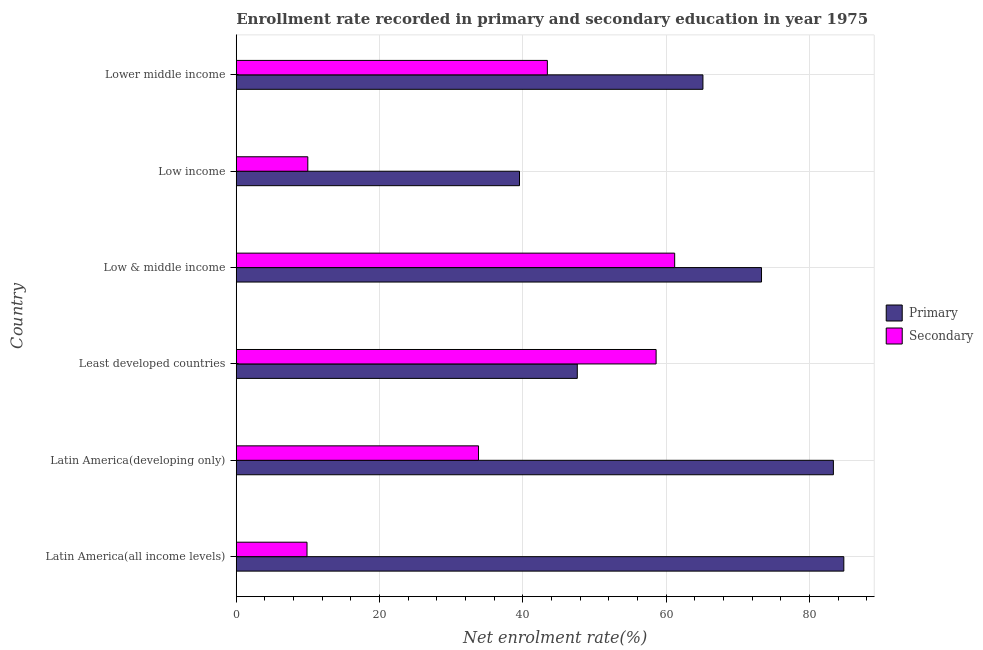How many groups of bars are there?
Offer a terse response. 6. Are the number of bars per tick equal to the number of legend labels?
Offer a terse response. Yes. Are the number of bars on each tick of the Y-axis equal?
Offer a very short reply. Yes. How many bars are there on the 5th tick from the top?
Your answer should be compact. 2. How many bars are there on the 4th tick from the bottom?
Give a very brief answer. 2. What is the label of the 4th group of bars from the top?
Keep it short and to the point. Least developed countries. In how many cases, is the number of bars for a given country not equal to the number of legend labels?
Offer a terse response. 0. What is the enrollment rate in primary education in Low income?
Provide a short and direct response. 39.53. Across all countries, what is the maximum enrollment rate in primary education?
Ensure brevity in your answer.  84.79. Across all countries, what is the minimum enrollment rate in secondary education?
Your response must be concise. 9.88. In which country was the enrollment rate in primary education maximum?
Provide a succinct answer. Latin America(all income levels). What is the total enrollment rate in primary education in the graph?
Provide a succinct answer. 393.66. What is the difference between the enrollment rate in secondary education in Low & middle income and that in Lower middle income?
Keep it short and to the point. 17.77. What is the difference between the enrollment rate in primary education in Least developed countries and the enrollment rate in secondary education in Low income?
Keep it short and to the point. 37.61. What is the average enrollment rate in primary education per country?
Provide a succinct answer. 65.61. What is the difference between the enrollment rate in secondary education and enrollment rate in primary education in Lower middle income?
Keep it short and to the point. -21.71. In how many countries, is the enrollment rate in primary education greater than 84 %?
Give a very brief answer. 1. What is the ratio of the enrollment rate in primary education in Latin America(developing only) to that in Low income?
Your answer should be very brief. 2.11. Is the difference between the enrollment rate in primary education in Least developed countries and Low income greater than the difference between the enrollment rate in secondary education in Least developed countries and Low income?
Keep it short and to the point. No. What is the difference between the highest and the second highest enrollment rate in secondary education?
Ensure brevity in your answer.  2.59. What is the difference between the highest and the lowest enrollment rate in primary education?
Ensure brevity in your answer.  45.26. What does the 1st bar from the top in Low & middle income represents?
Provide a short and direct response. Secondary. What does the 2nd bar from the bottom in Latin America(developing only) represents?
Your answer should be compact. Secondary. How many countries are there in the graph?
Ensure brevity in your answer.  6. Does the graph contain grids?
Provide a short and direct response. Yes. How are the legend labels stacked?
Your answer should be compact. Vertical. What is the title of the graph?
Your answer should be compact. Enrollment rate recorded in primary and secondary education in year 1975. What is the label or title of the X-axis?
Ensure brevity in your answer.  Net enrolment rate(%). What is the label or title of the Y-axis?
Your answer should be compact. Country. What is the Net enrolment rate(%) in Primary in Latin America(all income levels)?
Provide a succinct answer. 84.79. What is the Net enrolment rate(%) of Secondary in Latin America(all income levels)?
Make the answer very short. 9.88. What is the Net enrolment rate(%) in Primary in Latin America(developing only)?
Keep it short and to the point. 83.33. What is the Net enrolment rate(%) in Secondary in Latin America(developing only)?
Provide a short and direct response. 33.81. What is the Net enrolment rate(%) of Primary in Least developed countries?
Offer a terse response. 47.59. What is the Net enrolment rate(%) of Secondary in Least developed countries?
Your answer should be compact. 58.59. What is the Net enrolment rate(%) of Primary in Low & middle income?
Give a very brief answer. 73.3. What is the Net enrolment rate(%) in Secondary in Low & middle income?
Your answer should be compact. 61.18. What is the Net enrolment rate(%) of Primary in Low income?
Your answer should be compact. 39.53. What is the Net enrolment rate(%) in Secondary in Low income?
Offer a terse response. 9.99. What is the Net enrolment rate(%) in Primary in Lower middle income?
Make the answer very short. 65.13. What is the Net enrolment rate(%) of Secondary in Lower middle income?
Your answer should be very brief. 43.42. Across all countries, what is the maximum Net enrolment rate(%) of Primary?
Your answer should be very brief. 84.79. Across all countries, what is the maximum Net enrolment rate(%) in Secondary?
Ensure brevity in your answer.  61.18. Across all countries, what is the minimum Net enrolment rate(%) in Primary?
Make the answer very short. 39.53. Across all countries, what is the minimum Net enrolment rate(%) of Secondary?
Your response must be concise. 9.88. What is the total Net enrolment rate(%) of Primary in the graph?
Offer a terse response. 393.66. What is the total Net enrolment rate(%) in Secondary in the graph?
Your response must be concise. 216.85. What is the difference between the Net enrolment rate(%) of Primary in Latin America(all income levels) and that in Latin America(developing only)?
Your answer should be very brief. 1.46. What is the difference between the Net enrolment rate(%) in Secondary in Latin America(all income levels) and that in Latin America(developing only)?
Offer a terse response. -23.93. What is the difference between the Net enrolment rate(%) in Primary in Latin America(all income levels) and that in Least developed countries?
Your answer should be very brief. 37.19. What is the difference between the Net enrolment rate(%) in Secondary in Latin America(all income levels) and that in Least developed countries?
Provide a succinct answer. -48.71. What is the difference between the Net enrolment rate(%) in Primary in Latin America(all income levels) and that in Low & middle income?
Ensure brevity in your answer.  11.49. What is the difference between the Net enrolment rate(%) in Secondary in Latin America(all income levels) and that in Low & middle income?
Your response must be concise. -51.31. What is the difference between the Net enrolment rate(%) of Primary in Latin America(all income levels) and that in Low income?
Make the answer very short. 45.26. What is the difference between the Net enrolment rate(%) in Secondary in Latin America(all income levels) and that in Low income?
Provide a succinct answer. -0.11. What is the difference between the Net enrolment rate(%) of Primary in Latin America(all income levels) and that in Lower middle income?
Provide a short and direct response. 19.66. What is the difference between the Net enrolment rate(%) of Secondary in Latin America(all income levels) and that in Lower middle income?
Keep it short and to the point. -33.54. What is the difference between the Net enrolment rate(%) in Primary in Latin America(developing only) and that in Least developed countries?
Your answer should be compact. 35.74. What is the difference between the Net enrolment rate(%) in Secondary in Latin America(developing only) and that in Least developed countries?
Offer a very short reply. -24.78. What is the difference between the Net enrolment rate(%) in Primary in Latin America(developing only) and that in Low & middle income?
Keep it short and to the point. 10.03. What is the difference between the Net enrolment rate(%) in Secondary in Latin America(developing only) and that in Low & middle income?
Keep it short and to the point. -27.37. What is the difference between the Net enrolment rate(%) in Primary in Latin America(developing only) and that in Low income?
Your answer should be very brief. 43.8. What is the difference between the Net enrolment rate(%) of Secondary in Latin America(developing only) and that in Low income?
Make the answer very short. 23.82. What is the difference between the Net enrolment rate(%) in Primary in Latin America(developing only) and that in Lower middle income?
Offer a very short reply. 18.2. What is the difference between the Net enrolment rate(%) in Secondary in Latin America(developing only) and that in Lower middle income?
Give a very brief answer. -9.61. What is the difference between the Net enrolment rate(%) of Primary in Least developed countries and that in Low & middle income?
Keep it short and to the point. -25.71. What is the difference between the Net enrolment rate(%) of Secondary in Least developed countries and that in Low & middle income?
Ensure brevity in your answer.  -2.59. What is the difference between the Net enrolment rate(%) of Primary in Least developed countries and that in Low income?
Offer a terse response. 8.07. What is the difference between the Net enrolment rate(%) in Secondary in Least developed countries and that in Low income?
Provide a short and direct response. 48.6. What is the difference between the Net enrolment rate(%) of Primary in Least developed countries and that in Lower middle income?
Ensure brevity in your answer.  -17.53. What is the difference between the Net enrolment rate(%) of Secondary in Least developed countries and that in Lower middle income?
Offer a very short reply. 15.17. What is the difference between the Net enrolment rate(%) of Primary in Low & middle income and that in Low income?
Offer a very short reply. 33.77. What is the difference between the Net enrolment rate(%) in Secondary in Low & middle income and that in Low income?
Make the answer very short. 51.2. What is the difference between the Net enrolment rate(%) in Primary in Low & middle income and that in Lower middle income?
Offer a terse response. 8.17. What is the difference between the Net enrolment rate(%) of Secondary in Low & middle income and that in Lower middle income?
Your response must be concise. 17.77. What is the difference between the Net enrolment rate(%) in Primary in Low income and that in Lower middle income?
Your answer should be very brief. -25.6. What is the difference between the Net enrolment rate(%) of Secondary in Low income and that in Lower middle income?
Provide a succinct answer. -33.43. What is the difference between the Net enrolment rate(%) in Primary in Latin America(all income levels) and the Net enrolment rate(%) in Secondary in Latin America(developing only)?
Give a very brief answer. 50.98. What is the difference between the Net enrolment rate(%) in Primary in Latin America(all income levels) and the Net enrolment rate(%) in Secondary in Least developed countries?
Offer a very short reply. 26.2. What is the difference between the Net enrolment rate(%) of Primary in Latin America(all income levels) and the Net enrolment rate(%) of Secondary in Low & middle income?
Provide a succinct answer. 23.61. What is the difference between the Net enrolment rate(%) in Primary in Latin America(all income levels) and the Net enrolment rate(%) in Secondary in Low income?
Provide a short and direct response. 74.8. What is the difference between the Net enrolment rate(%) in Primary in Latin America(all income levels) and the Net enrolment rate(%) in Secondary in Lower middle income?
Provide a short and direct response. 41.37. What is the difference between the Net enrolment rate(%) in Primary in Latin America(developing only) and the Net enrolment rate(%) in Secondary in Least developed countries?
Offer a very short reply. 24.74. What is the difference between the Net enrolment rate(%) in Primary in Latin America(developing only) and the Net enrolment rate(%) in Secondary in Low & middle income?
Your response must be concise. 22.15. What is the difference between the Net enrolment rate(%) of Primary in Latin America(developing only) and the Net enrolment rate(%) of Secondary in Low income?
Offer a very short reply. 73.34. What is the difference between the Net enrolment rate(%) in Primary in Latin America(developing only) and the Net enrolment rate(%) in Secondary in Lower middle income?
Offer a terse response. 39.92. What is the difference between the Net enrolment rate(%) of Primary in Least developed countries and the Net enrolment rate(%) of Secondary in Low & middle income?
Provide a short and direct response. -13.59. What is the difference between the Net enrolment rate(%) in Primary in Least developed countries and the Net enrolment rate(%) in Secondary in Low income?
Your answer should be very brief. 37.61. What is the difference between the Net enrolment rate(%) in Primary in Least developed countries and the Net enrolment rate(%) in Secondary in Lower middle income?
Keep it short and to the point. 4.18. What is the difference between the Net enrolment rate(%) of Primary in Low & middle income and the Net enrolment rate(%) of Secondary in Low income?
Ensure brevity in your answer.  63.31. What is the difference between the Net enrolment rate(%) of Primary in Low & middle income and the Net enrolment rate(%) of Secondary in Lower middle income?
Your answer should be very brief. 29.88. What is the difference between the Net enrolment rate(%) in Primary in Low income and the Net enrolment rate(%) in Secondary in Lower middle income?
Make the answer very short. -3.89. What is the average Net enrolment rate(%) in Primary per country?
Make the answer very short. 65.61. What is the average Net enrolment rate(%) in Secondary per country?
Offer a terse response. 36.14. What is the difference between the Net enrolment rate(%) in Primary and Net enrolment rate(%) in Secondary in Latin America(all income levels)?
Make the answer very short. 74.91. What is the difference between the Net enrolment rate(%) of Primary and Net enrolment rate(%) of Secondary in Latin America(developing only)?
Ensure brevity in your answer.  49.52. What is the difference between the Net enrolment rate(%) in Primary and Net enrolment rate(%) in Secondary in Least developed countries?
Your answer should be very brief. -11. What is the difference between the Net enrolment rate(%) of Primary and Net enrolment rate(%) of Secondary in Low & middle income?
Offer a terse response. 12.12. What is the difference between the Net enrolment rate(%) of Primary and Net enrolment rate(%) of Secondary in Low income?
Your answer should be compact. 29.54. What is the difference between the Net enrolment rate(%) in Primary and Net enrolment rate(%) in Secondary in Lower middle income?
Give a very brief answer. 21.71. What is the ratio of the Net enrolment rate(%) in Primary in Latin America(all income levels) to that in Latin America(developing only)?
Your answer should be very brief. 1.02. What is the ratio of the Net enrolment rate(%) in Secondary in Latin America(all income levels) to that in Latin America(developing only)?
Your answer should be very brief. 0.29. What is the ratio of the Net enrolment rate(%) of Primary in Latin America(all income levels) to that in Least developed countries?
Offer a terse response. 1.78. What is the ratio of the Net enrolment rate(%) of Secondary in Latin America(all income levels) to that in Least developed countries?
Your answer should be compact. 0.17. What is the ratio of the Net enrolment rate(%) of Primary in Latin America(all income levels) to that in Low & middle income?
Provide a succinct answer. 1.16. What is the ratio of the Net enrolment rate(%) of Secondary in Latin America(all income levels) to that in Low & middle income?
Give a very brief answer. 0.16. What is the ratio of the Net enrolment rate(%) of Primary in Latin America(all income levels) to that in Low income?
Your answer should be very brief. 2.15. What is the ratio of the Net enrolment rate(%) of Secondary in Latin America(all income levels) to that in Low income?
Give a very brief answer. 0.99. What is the ratio of the Net enrolment rate(%) of Primary in Latin America(all income levels) to that in Lower middle income?
Provide a short and direct response. 1.3. What is the ratio of the Net enrolment rate(%) of Secondary in Latin America(all income levels) to that in Lower middle income?
Your response must be concise. 0.23. What is the ratio of the Net enrolment rate(%) in Primary in Latin America(developing only) to that in Least developed countries?
Offer a terse response. 1.75. What is the ratio of the Net enrolment rate(%) in Secondary in Latin America(developing only) to that in Least developed countries?
Offer a terse response. 0.58. What is the ratio of the Net enrolment rate(%) of Primary in Latin America(developing only) to that in Low & middle income?
Keep it short and to the point. 1.14. What is the ratio of the Net enrolment rate(%) in Secondary in Latin America(developing only) to that in Low & middle income?
Provide a succinct answer. 0.55. What is the ratio of the Net enrolment rate(%) in Primary in Latin America(developing only) to that in Low income?
Keep it short and to the point. 2.11. What is the ratio of the Net enrolment rate(%) in Secondary in Latin America(developing only) to that in Low income?
Your answer should be compact. 3.39. What is the ratio of the Net enrolment rate(%) of Primary in Latin America(developing only) to that in Lower middle income?
Keep it short and to the point. 1.28. What is the ratio of the Net enrolment rate(%) of Secondary in Latin America(developing only) to that in Lower middle income?
Your answer should be very brief. 0.78. What is the ratio of the Net enrolment rate(%) in Primary in Least developed countries to that in Low & middle income?
Make the answer very short. 0.65. What is the ratio of the Net enrolment rate(%) of Secondary in Least developed countries to that in Low & middle income?
Keep it short and to the point. 0.96. What is the ratio of the Net enrolment rate(%) of Primary in Least developed countries to that in Low income?
Offer a terse response. 1.2. What is the ratio of the Net enrolment rate(%) of Secondary in Least developed countries to that in Low income?
Ensure brevity in your answer.  5.87. What is the ratio of the Net enrolment rate(%) of Primary in Least developed countries to that in Lower middle income?
Your answer should be compact. 0.73. What is the ratio of the Net enrolment rate(%) of Secondary in Least developed countries to that in Lower middle income?
Ensure brevity in your answer.  1.35. What is the ratio of the Net enrolment rate(%) in Primary in Low & middle income to that in Low income?
Your answer should be very brief. 1.85. What is the ratio of the Net enrolment rate(%) of Secondary in Low & middle income to that in Low income?
Offer a very short reply. 6.13. What is the ratio of the Net enrolment rate(%) of Primary in Low & middle income to that in Lower middle income?
Give a very brief answer. 1.13. What is the ratio of the Net enrolment rate(%) in Secondary in Low & middle income to that in Lower middle income?
Offer a very short reply. 1.41. What is the ratio of the Net enrolment rate(%) in Primary in Low income to that in Lower middle income?
Your response must be concise. 0.61. What is the ratio of the Net enrolment rate(%) of Secondary in Low income to that in Lower middle income?
Your response must be concise. 0.23. What is the difference between the highest and the second highest Net enrolment rate(%) in Primary?
Your answer should be compact. 1.46. What is the difference between the highest and the second highest Net enrolment rate(%) in Secondary?
Give a very brief answer. 2.59. What is the difference between the highest and the lowest Net enrolment rate(%) in Primary?
Ensure brevity in your answer.  45.26. What is the difference between the highest and the lowest Net enrolment rate(%) of Secondary?
Provide a short and direct response. 51.31. 